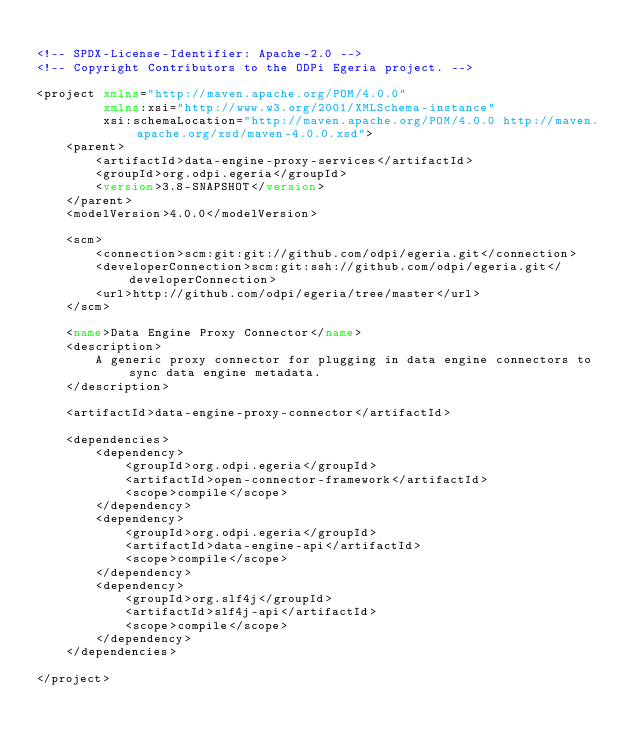Convert code to text. <code><loc_0><loc_0><loc_500><loc_500><_XML_>
<!-- SPDX-License-Identifier: Apache-2.0 -->
<!-- Copyright Contributors to the ODPi Egeria project. -->

<project xmlns="http://maven.apache.org/POM/4.0.0"
         xmlns:xsi="http://www.w3.org/2001/XMLSchema-instance"
         xsi:schemaLocation="http://maven.apache.org/POM/4.0.0 http://maven.apache.org/xsd/maven-4.0.0.xsd">
    <parent>
        <artifactId>data-engine-proxy-services</artifactId>
        <groupId>org.odpi.egeria</groupId>
        <version>3.8-SNAPSHOT</version>
    </parent>
    <modelVersion>4.0.0</modelVersion>

    <scm>
        <connection>scm:git:git://github.com/odpi/egeria.git</connection>
        <developerConnection>scm:git:ssh://github.com/odpi/egeria.git</developerConnection>
        <url>http://github.com/odpi/egeria/tree/master</url>
    </scm>

    <name>Data Engine Proxy Connector</name>
    <description>
        A generic proxy connector for plugging in data engine connectors to sync data engine metadata.
    </description>

    <artifactId>data-engine-proxy-connector</artifactId>

    <dependencies>
        <dependency>
            <groupId>org.odpi.egeria</groupId>
            <artifactId>open-connector-framework</artifactId>
            <scope>compile</scope>
        </dependency>
        <dependency>
            <groupId>org.odpi.egeria</groupId>
            <artifactId>data-engine-api</artifactId>
            <scope>compile</scope>
        </dependency>
        <dependency>
            <groupId>org.slf4j</groupId>
            <artifactId>slf4j-api</artifactId>
            <scope>compile</scope>
        </dependency>
    </dependencies>

</project>
</code> 